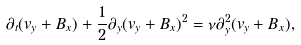Convert formula to latex. <formula><loc_0><loc_0><loc_500><loc_500>\partial _ { t } ( v _ { y } + B _ { x } ) + \frac { 1 } { 2 } \partial _ { y } ( v _ { y } + B _ { x } ) ^ { 2 } = \nu \partial _ { y } ^ { 2 } ( v _ { y } + B _ { x } ) ,</formula> 